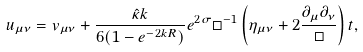Convert formula to latex. <formula><loc_0><loc_0><loc_500><loc_500>u _ { \mu \nu } = v _ { \mu \nu } + \frac { \hat { \kappa } k } { 6 ( 1 - e ^ { - 2 k R } ) } e ^ { 2 \sigma } \Box ^ { - 1 } \left ( \eta _ { \mu \nu } + 2 \frac { \partial _ { \mu } \partial _ { \nu } } { \Box } \right ) t ,</formula> 